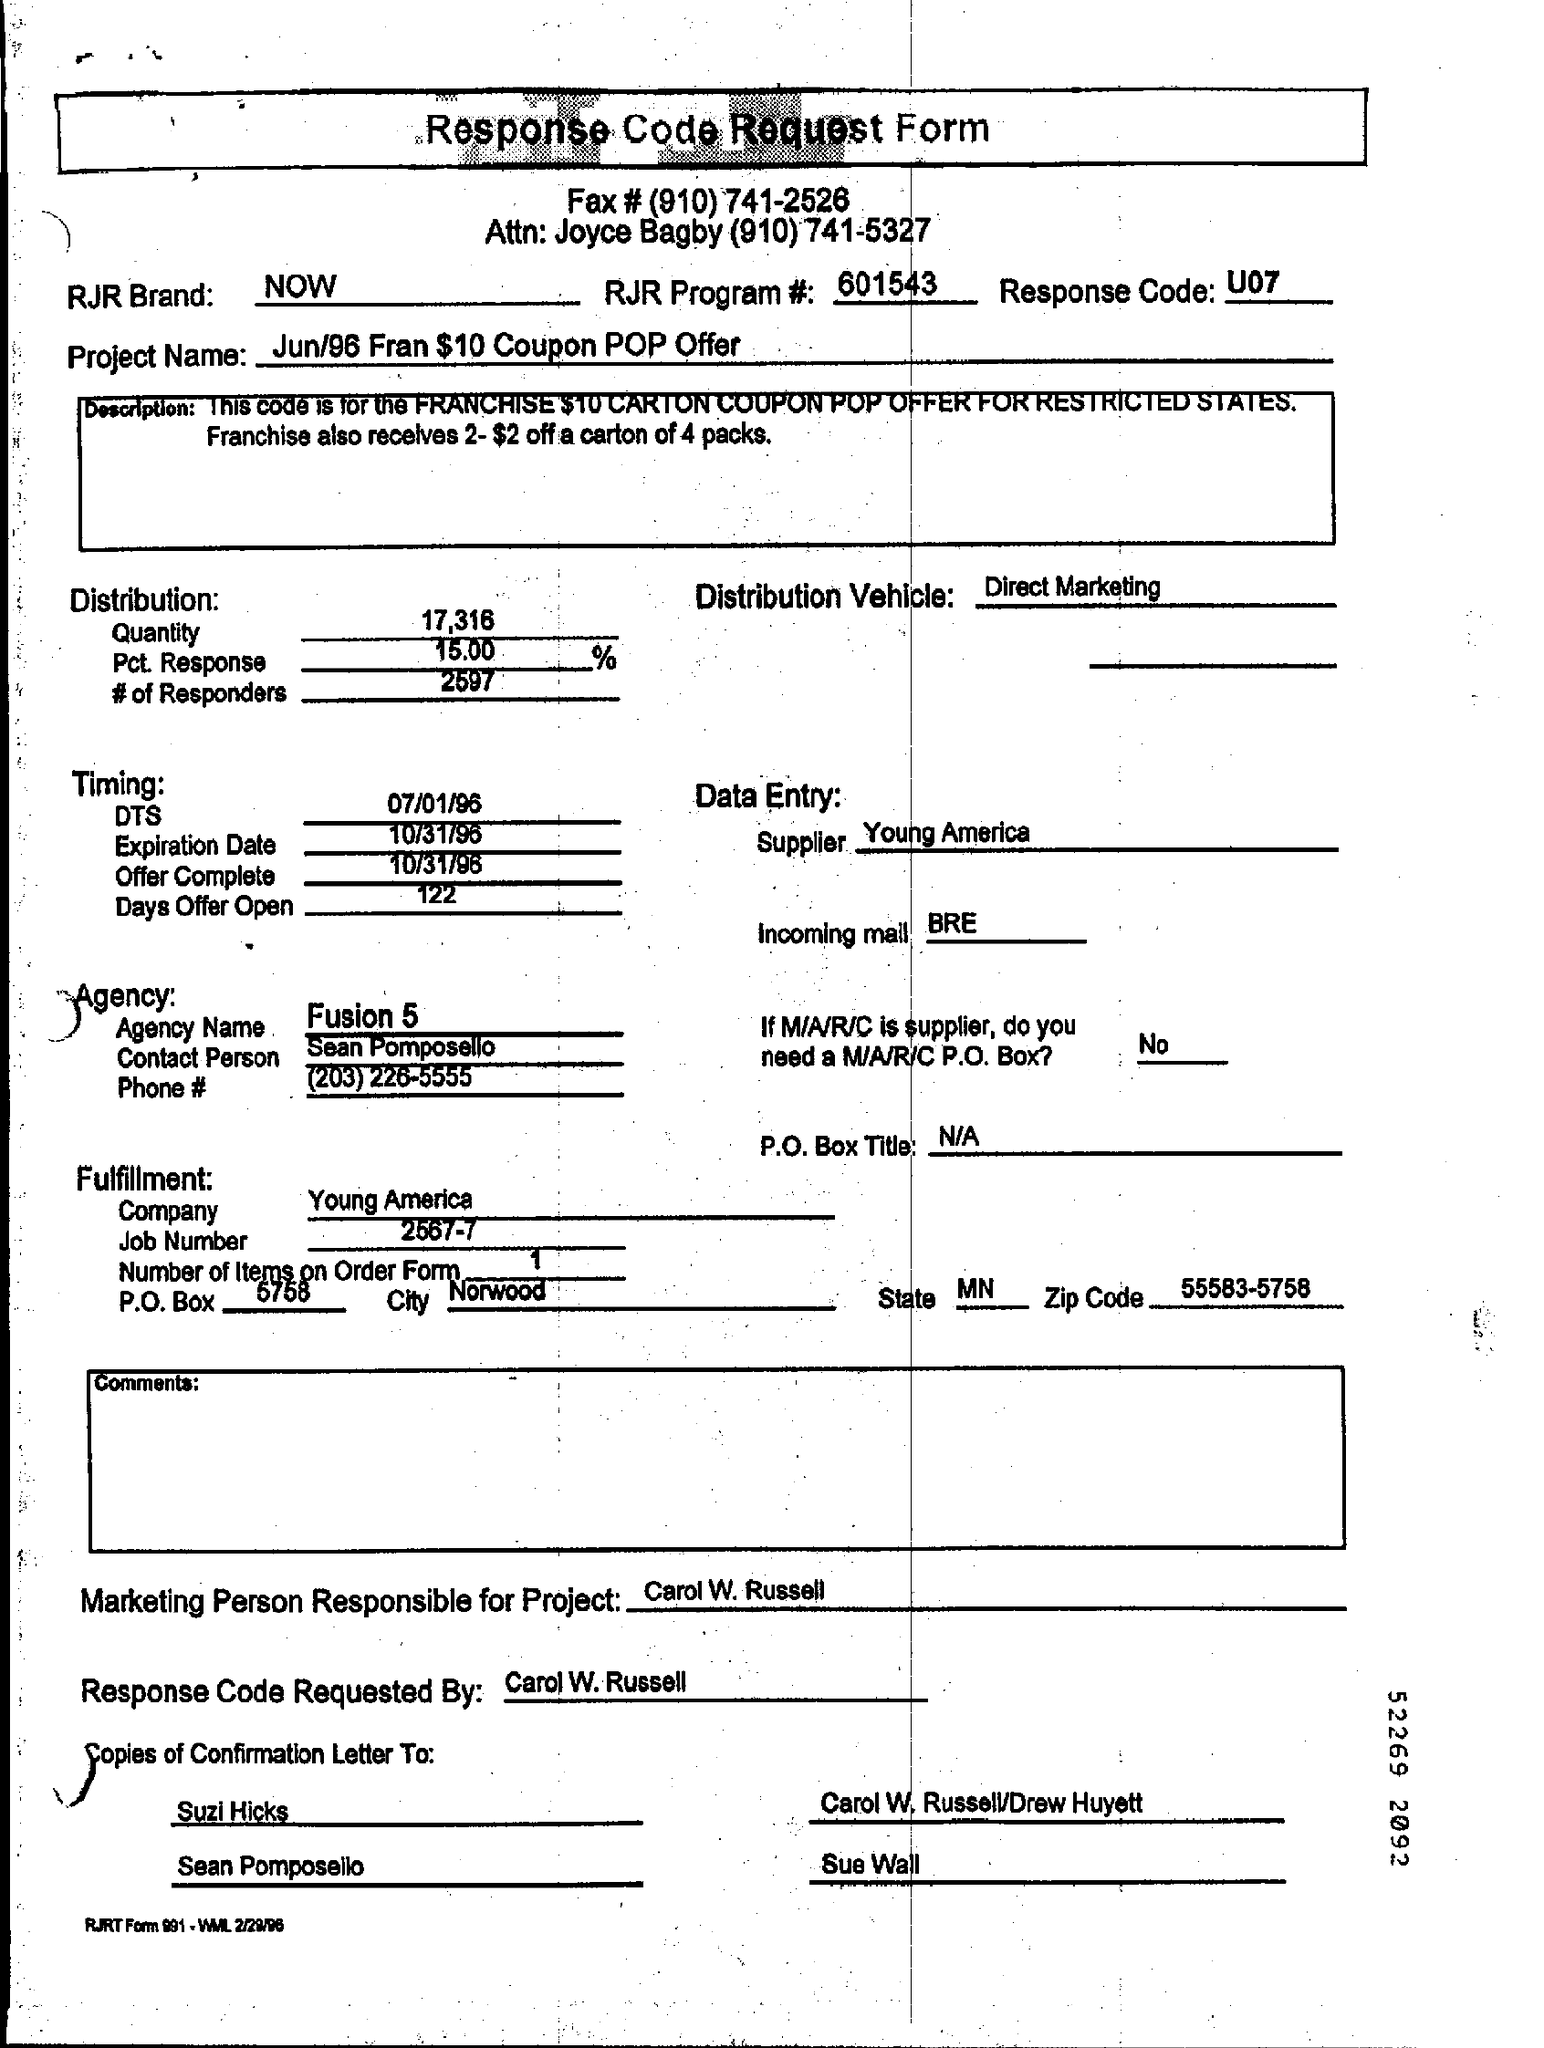Which form is this
Make the answer very short. Response Code Request Form. What is the Project Name given in this form
Your answer should be compact. Jun/96 fran $10 coupon pop offer. What is the Response Code given
Provide a short and direct response. U07. 